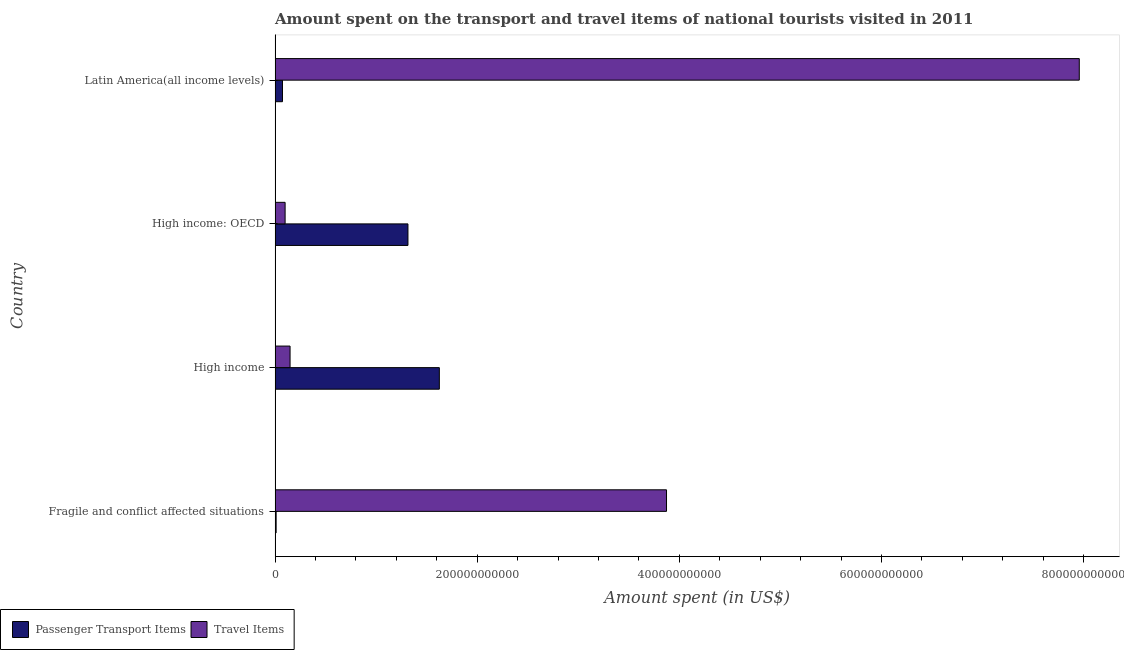How many groups of bars are there?
Provide a succinct answer. 4. Are the number of bars per tick equal to the number of legend labels?
Your answer should be very brief. Yes. Are the number of bars on each tick of the Y-axis equal?
Your answer should be very brief. Yes. How many bars are there on the 1st tick from the top?
Give a very brief answer. 2. What is the label of the 4th group of bars from the top?
Make the answer very short. Fragile and conflict affected situations. In how many cases, is the number of bars for a given country not equal to the number of legend labels?
Make the answer very short. 0. What is the amount spent on passenger transport items in Latin America(all income levels)?
Your answer should be compact. 7.33e+09. Across all countries, what is the maximum amount spent on passenger transport items?
Your answer should be very brief. 1.63e+11. Across all countries, what is the minimum amount spent in travel items?
Provide a succinct answer. 9.92e+09. In which country was the amount spent on passenger transport items minimum?
Ensure brevity in your answer.  Fragile and conflict affected situations. What is the total amount spent on passenger transport items in the graph?
Your answer should be compact. 3.02e+11. What is the difference between the amount spent on passenger transport items in Fragile and conflict affected situations and that in Latin America(all income levels)?
Keep it short and to the point. -6.29e+09. What is the difference between the amount spent on passenger transport items in High income and the amount spent in travel items in High income: OECD?
Your response must be concise. 1.53e+11. What is the average amount spent in travel items per country?
Give a very brief answer. 3.02e+11. What is the difference between the amount spent in travel items and amount spent on passenger transport items in High income?
Give a very brief answer. -1.48e+11. In how many countries, is the amount spent on passenger transport items greater than 240000000000 US$?
Provide a short and direct response. 0. What is the ratio of the amount spent on passenger transport items in Fragile and conflict affected situations to that in High income?
Your answer should be compact. 0.01. Is the amount spent in travel items in Fragile and conflict affected situations less than that in High income: OECD?
Keep it short and to the point. No. Is the difference between the amount spent in travel items in Fragile and conflict affected situations and High income greater than the difference between the amount spent on passenger transport items in Fragile and conflict affected situations and High income?
Provide a succinct answer. Yes. What is the difference between the highest and the second highest amount spent on passenger transport items?
Provide a succinct answer. 3.11e+1. What is the difference between the highest and the lowest amount spent on passenger transport items?
Your answer should be compact. 1.61e+11. In how many countries, is the amount spent on passenger transport items greater than the average amount spent on passenger transport items taken over all countries?
Provide a short and direct response. 2. Is the sum of the amount spent in travel items in Fragile and conflict affected situations and High income greater than the maximum amount spent on passenger transport items across all countries?
Provide a short and direct response. Yes. What does the 1st bar from the top in Latin America(all income levels) represents?
Offer a very short reply. Travel Items. What does the 1st bar from the bottom in Fragile and conflict affected situations represents?
Your answer should be very brief. Passenger Transport Items. How many bars are there?
Your response must be concise. 8. Are all the bars in the graph horizontal?
Your answer should be very brief. Yes. What is the difference between two consecutive major ticks on the X-axis?
Offer a very short reply. 2.00e+11. Does the graph contain grids?
Ensure brevity in your answer.  No. Where does the legend appear in the graph?
Give a very brief answer. Bottom left. What is the title of the graph?
Provide a succinct answer. Amount spent on the transport and travel items of national tourists visited in 2011. What is the label or title of the X-axis?
Your answer should be compact. Amount spent (in US$). What is the label or title of the Y-axis?
Ensure brevity in your answer.  Country. What is the Amount spent (in US$) in Passenger Transport Items in Fragile and conflict affected situations?
Your response must be concise. 1.04e+09. What is the Amount spent (in US$) in Travel Items in Fragile and conflict affected situations?
Your answer should be compact. 3.87e+11. What is the Amount spent (in US$) of Passenger Transport Items in High income?
Your response must be concise. 1.63e+11. What is the Amount spent (in US$) in Travel Items in High income?
Your response must be concise. 1.48e+1. What is the Amount spent (in US$) of Passenger Transport Items in High income: OECD?
Make the answer very short. 1.31e+11. What is the Amount spent (in US$) of Travel Items in High income: OECD?
Keep it short and to the point. 9.92e+09. What is the Amount spent (in US$) in Passenger Transport Items in Latin America(all income levels)?
Your response must be concise. 7.33e+09. What is the Amount spent (in US$) in Travel Items in Latin America(all income levels)?
Make the answer very short. 7.96e+11. Across all countries, what is the maximum Amount spent (in US$) in Passenger Transport Items?
Offer a terse response. 1.63e+11. Across all countries, what is the maximum Amount spent (in US$) of Travel Items?
Ensure brevity in your answer.  7.96e+11. Across all countries, what is the minimum Amount spent (in US$) in Passenger Transport Items?
Make the answer very short. 1.04e+09. Across all countries, what is the minimum Amount spent (in US$) of Travel Items?
Your answer should be very brief. 9.92e+09. What is the total Amount spent (in US$) in Passenger Transport Items in the graph?
Make the answer very short. 3.02e+11. What is the total Amount spent (in US$) in Travel Items in the graph?
Provide a short and direct response. 1.21e+12. What is the difference between the Amount spent (in US$) of Passenger Transport Items in Fragile and conflict affected situations and that in High income?
Your answer should be compact. -1.61e+11. What is the difference between the Amount spent (in US$) of Travel Items in Fragile and conflict affected situations and that in High income?
Make the answer very short. 3.72e+11. What is the difference between the Amount spent (in US$) in Passenger Transport Items in Fragile and conflict affected situations and that in High income: OECD?
Provide a succinct answer. -1.30e+11. What is the difference between the Amount spent (in US$) in Travel Items in Fragile and conflict affected situations and that in High income: OECD?
Offer a very short reply. 3.77e+11. What is the difference between the Amount spent (in US$) of Passenger Transport Items in Fragile and conflict affected situations and that in Latin America(all income levels)?
Give a very brief answer. -6.29e+09. What is the difference between the Amount spent (in US$) of Travel Items in Fragile and conflict affected situations and that in Latin America(all income levels)?
Your response must be concise. -4.08e+11. What is the difference between the Amount spent (in US$) of Passenger Transport Items in High income and that in High income: OECD?
Provide a short and direct response. 3.11e+1. What is the difference between the Amount spent (in US$) in Travel Items in High income and that in High income: OECD?
Your answer should be very brief. 4.91e+09. What is the difference between the Amount spent (in US$) of Passenger Transport Items in High income and that in Latin America(all income levels)?
Provide a succinct answer. 1.55e+11. What is the difference between the Amount spent (in US$) of Travel Items in High income and that in Latin America(all income levels)?
Provide a succinct answer. -7.81e+11. What is the difference between the Amount spent (in US$) of Passenger Transport Items in High income: OECD and that in Latin America(all income levels)?
Offer a terse response. 1.24e+11. What is the difference between the Amount spent (in US$) in Travel Items in High income: OECD and that in Latin America(all income levels)?
Your answer should be very brief. -7.86e+11. What is the difference between the Amount spent (in US$) in Passenger Transport Items in Fragile and conflict affected situations and the Amount spent (in US$) in Travel Items in High income?
Provide a short and direct response. -1.38e+1. What is the difference between the Amount spent (in US$) in Passenger Transport Items in Fragile and conflict affected situations and the Amount spent (in US$) in Travel Items in High income: OECD?
Keep it short and to the point. -8.88e+09. What is the difference between the Amount spent (in US$) of Passenger Transport Items in Fragile and conflict affected situations and the Amount spent (in US$) of Travel Items in Latin America(all income levels)?
Your answer should be compact. -7.95e+11. What is the difference between the Amount spent (in US$) of Passenger Transport Items in High income and the Amount spent (in US$) of Travel Items in High income: OECD?
Make the answer very short. 1.53e+11. What is the difference between the Amount spent (in US$) in Passenger Transport Items in High income and the Amount spent (in US$) in Travel Items in Latin America(all income levels)?
Your response must be concise. -6.33e+11. What is the difference between the Amount spent (in US$) in Passenger Transport Items in High income: OECD and the Amount spent (in US$) in Travel Items in Latin America(all income levels)?
Ensure brevity in your answer.  -6.64e+11. What is the average Amount spent (in US$) in Passenger Transport Items per country?
Provide a succinct answer. 7.56e+1. What is the average Amount spent (in US$) of Travel Items per country?
Make the answer very short. 3.02e+11. What is the difference between the Amount spent (in US$) of Passenger Transport Items and Amount spent (in US$) of Travel Items in Fragile and conflict affected situations?
Offer a very short reply. -3.86e+11. What is the difference between the Amount spent (in US$) in Passenger Transport Items and Amount spent (in US$) in Travel Items in High income?
Provide a short and direct response. 1.48e+11. What is the difference between the Amount spent (in US$) of Passenger Transport Items and Amount spent (in US$) of Travel Items in High income: OECD?
Keep it short and to the point. 1.22e+11. What is the difference between the Amount spent (in US$) in Passenger Transport Items and Amount spent (in US$) in Travel Items in Latin America(all income levels)?
Make the answer very short. -7.88e+11. What is the ratio of the Amount spent (in US$) of Passenger Transport Items in Fragile and conflict affected situations to that in High income?
Provide a short and direct response. 0.01. What is the ratio of the Amount spent (in US$) of Travel Items in Fragile and conflict affected situations to that in High income?
Offer a very short reply. 26.12. What is the ratio of the Amount spent (in US$) of Passenger Transport Items in Fragile and conflict affected situations to that in High income: OECD?
Provide a succinct answer. 0.01. What is the ratio of the Amount spent (in US$) of Travel Items in Fragile and conflict affected situations to that in High income: OECD?
Make the answer very short. 39.05. What is the ratio of the Amount spent (in US$) of Passenger Transport Items in Fragile and conflict affected situations to that in Latin America(all income levels)?
Your answer should be compact. 0.14. What is the ratio of the Amount spent (in US$) of Travel Items in Fragile and conflict affected situations to that in Latin America(all income levels)?
Your answer should be compact. 0.49. What is the ratio of the Amount spent (in US$) in Passenger Transport Items in High income to that in High income: OECD?
Your answer should be very brief. 1.24. What is the ratio of the Amount spent (in US$) in Travel Items in High income to that in High income: OECD?
Offer a terse response. 1.5. What is the ratio of the Amount spent (in US$) of Passenger Transport Items in High income to that in Latin America(all income levels)?
Ensure brevity in your answer.  22.17. What is the ratio of the Amount spent (in US$) of Travel Items in High income to that in Latin America(all income levels)?
Offer a terse response. 0.02. What is the ratio of the Amount spent (in US$) in Passenger Transport Items in High income: OECD to that in Latin America(all income levels)?
Provide a succinct answer. 17.94. What is the ratio of the Amount spent (in US$) of Travel Items in High income: OECD to that in Latin America(all income levels)?
Your answer should be compact. 0.01. What is the difference between the highest and the second highest Amount spent (in US$) of Passenger Transport Items?
Make the answer very short. 3.11e+1. What is the difference between the highest and the second highest Amount spent (in US$) of Travel Items?
Ensure brevity in your answer.  4.08e+11. What is the difference between the highest and the lowest Amount spent (in US$) in Passenger Transport Items?
Make the answer very short. 1.61e+11. What is the difference between the highest and the lowest Amount spent (in US$) in Travel Items?
Offer a terse response. 7.86e+11. 